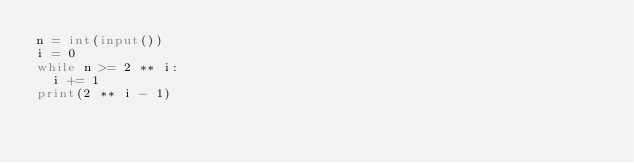<code> <loc_0><loc_0><loc_500><loc_500><_Python_>n = int(input())
i = 0
while n >= 2 ** i:
  i += 1
print(2 ** i - 1)</code> 